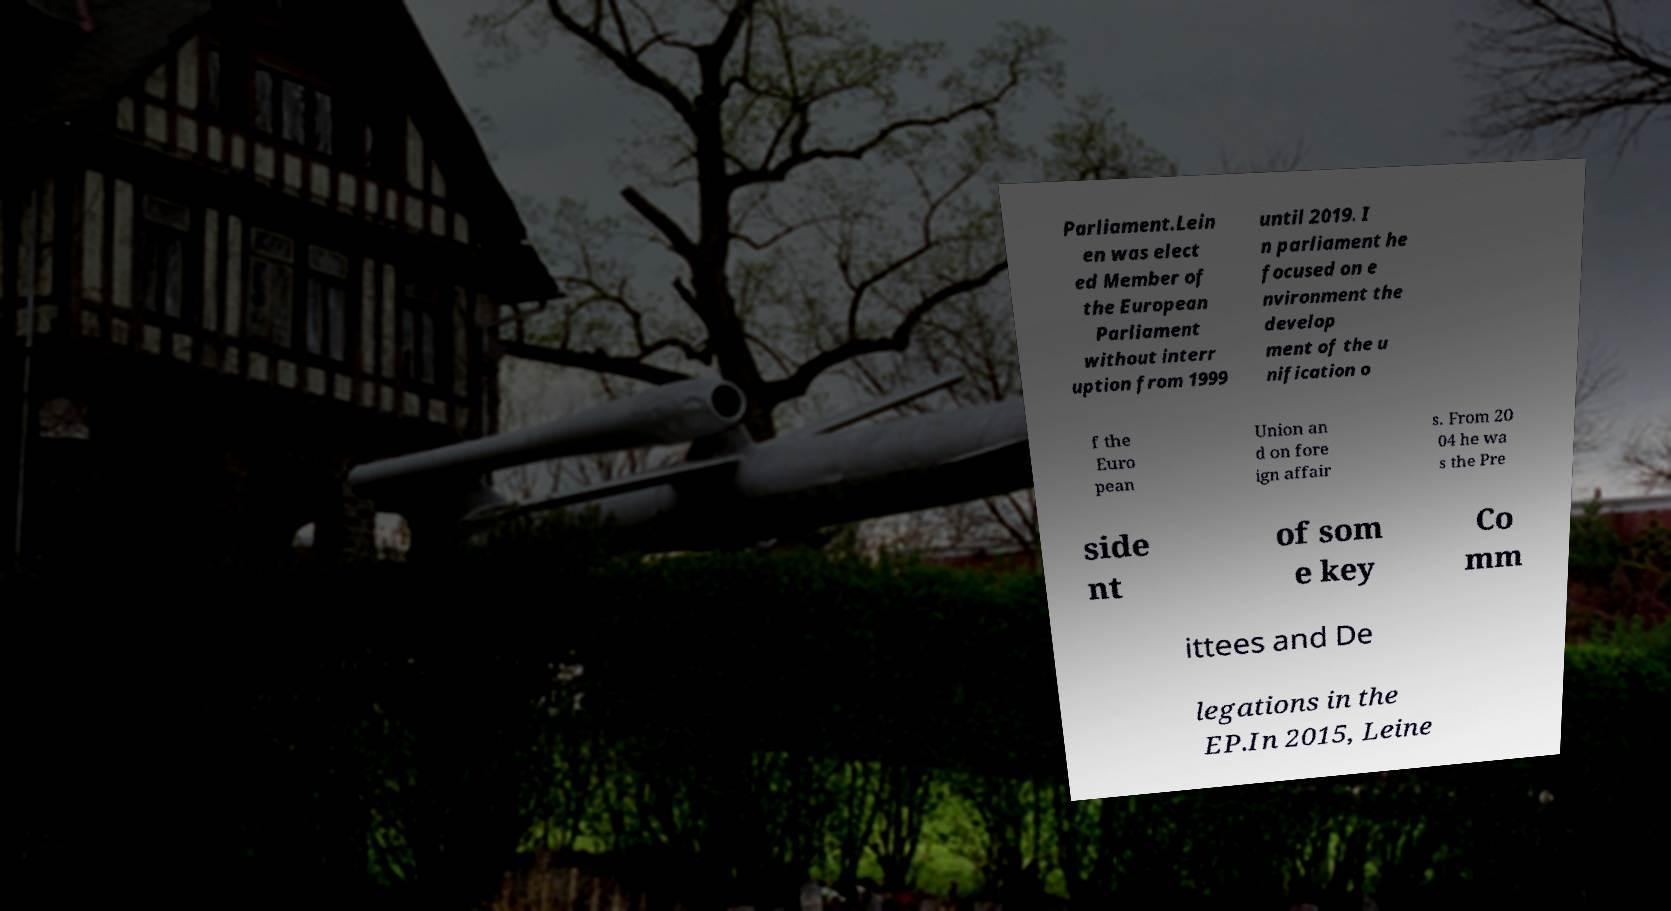Could you assist in decoding the text presented in this image and type it out clearly? Parliament.Lein en was elect ed Member of the European Parliament without interr uption from 1999 until 2019. I n parliament he focused on e nvironment the develop ment of the u nification o f the Euro pean Union an d on fore ign affair s. From 20 04 he wa s the Pre side nt of som e key Co mm ittees and De legations in the EP.In 2015, Leine 